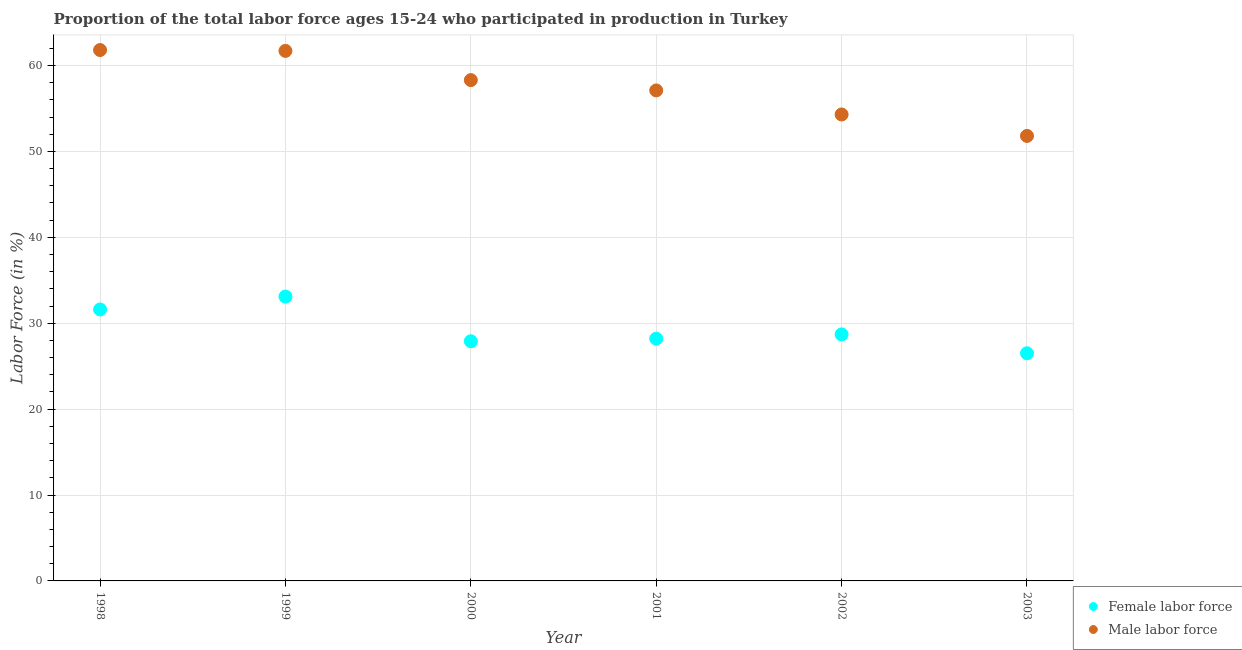Is the number of dotlines equal to the number of legend labels?
Your answer should be compact. Yes. What is the percentage of female labor force in 1999?
Your answer should be very brief. 33.1. Across all years, what is the maximum percentage of female labor force?
Offer a terse response. 33.1. Across all years, what is the minimum percentage of female labor force?
Make the answer very short. 26.5. In which year was the percentage of male labour force minimum?
Keep it short and to the point. 2003. What is the total percentage of female labor force in the graph?
Your response must be concise. 176. What is the difference between the percentage of female labor force in 2000 and that in 2002?
Offer a terse response. -0.8. What is the difference between the percentage of male labour force in 2002 and the percentage of female labor force in 1998?
Your answer should be compact. 22.7. What is the average percentage of female labor force per year?
Ensure brevity in your answer.  29.33. In the year 2000, what is the difference between the percentage of female labor force and percentage of male labour force?
Your answer should be very brief. -30.4. In how many years, is the percentage of female labor force greater than 58 %?
Offer a very short reply. 0. What is the ratio of the percentage of male labour force in 1998 to that in 2001?
Offer a very short reply. 1.08. Is the percentage of male labour force in 1998 less than that in 2002?
Provide a succinct answer. No. What is the difference between the highest and the second highest percentage of female labor force?
Give a very brief answer. 1.5. What is the difference between the highest and the lowest percentage of female labor force?
Ensure brevity in your answer.  6.6. Is the sum of the percentage of female labor force in 2000 and 2002 greater than the maximum percentage of male labour force across all years?
Make the answer very short. No. How many dotlines are there?
Provide a succinct answer. 2. What is the difference between two consecutive major ticks on the Y-axis?
Offer a terse response. 10. Are the values on the major ticks of Y-axis written in scientific E-notation?
Ensure brevity in your answer.  No. Does the graph contain any zero values?
Ensure brevity in your answer.  No. Does the graph contain grids?
Your answer should be very brief. Yes. How are the legend labels stacked?
Provide a succinct answer. Vertical. What is the title of the graph?
Provide a succinct answer. Proportion of the total labor force ages 15-24 who participated in production in Turkey. What is the label or title of the X-axis?
Offer a very short reply. Year. What is the Labor Force (in %) of Female labor force in 1998?
Offer a terse response. 31.6. What is the Labor Force (in %) in Male labor force in 1998?
Make the answer very short. 61.8. What is the Labor Force (in %) in Female labor force in 1999?
Offer a very short reply. 33.1. What is the Labor Force (in %) in Male labor force in 1999?
Offer a very short reply. 61.7. What is the Labor Force (in %) of Female labor force in 2000?
Keep it short and to the point. 27.9. What is the Labor Force (in %) of Male labor force in 2000?
Give a very brief answer. 58.3. What is the Labor Force (in %) in Female labor force in 2001?
Keep it short and to the point. 28.2. What is the Labor Force (in %) in Male labor force in 2001?
Make the answer very short. 57.1. What is the Labor Force (in %) of Female labor force in 2002?
Keep it short and to the point. 28.7. What is the Labor Force (in %) in Male labor force in 2002?
Provide a short and direct response. 54.3. What is the Labor Force (in %) of Male labor force in 2003?
Keep it short and to the point. 51.8. Across all years, what is the maximum Labor Force (in %) of Female labor force?
Ensure brevity in your answer.  33.1. Across all years, what is the maximum Labor Force (in %) in Male labor force?
Provide a succinct answer. 61.8. Across all years, what is the minimum Labor Force (in %) in Female labor force?
Your response must be concise. 26.5. Across all years, what is the minimum Labor Force (in %) of Male labor force?
Give a very brief answer. 51.8. What is the total Labor Force (in %) in Female labor force in the graph?
Ensure brevity in your answer.  176. What is the total Labor Force (in %) of Male labor force in the graph?
Make the answer very short. 345. What is the difference between the Labor Force (in %) of Female labor force in 1998 and that in 1999?
Provide a short and direct response. -1.5. What is the difference between the Labor Force (in %) of Male labor force in 1998 and that in 1999?
Your answer should be compact. 0.1. What is the difference between the Labor Force (in %) of Male labor force in 1998 and that in 2000?
Your answer should be compact. 3.5. What is the difference between the Labor Force (in %) of Female labor force in 1998 and that in 2001?
Provide a short and direct response. 3.4. What is the difference between the Labor Force (in %) in Male labor force in 1998 and that in 2001?
Offer a terse response. 4.7. What is the difference between the Labor Force (in %) in Male labor force in 1998 and that in 2002?
Your response must be concise. 7.5. What is the difference between the Labor Force (in %) of Female labor force in 1999 and that in 2000?
Your answer should be compact. 5.2. What is the difference between the Labor Force (in %) in Female labor force in 1999 and that in 2003?
Provide a succinct answer. 6.6. What is the difference between the Labor Force (in %) of Female labor force in 2000 and that in 2001?
Your answer should be very brief. -0.3. What is the difference between the Labor Force (in %) in Male labor force in 2000 and that in 2001?
Your response must be concise. 1.2. What is the difference between the Labor Force (in %) of Female labor force in 2000 and that in 2002?
Provide a succinct answer. -0.8. What is the difference between the Labor Force (in %) in Male labor force in 2000 and that in 2002?
Offer a very short reply. 4. What is the difference between the Labor Force (in %) of Female labor force in 2000 and that in 2003?
Offer a very short reply. 1.4. What is the difference between the Labor Force (in %) in Male labor force in 2000 and that in 2003?
Keep it short and to the point. 6.5. What is the difference between the Labor Force (in %) of Female labor force in 2001 and that in 2002?
Your response must be concise. -0.5. What is the difference between the Labor Force (in %) of Male labor force in 2001 and that in 2002?
Offer a terse response. 2.8. What is the difference between the Labor Force (in %) of Female labor force in 2001 and that in 2003?
Make the answer very short. 1.7. What is the difference between the Labor Force (in %) in Male labor force in 2001 and that in 2003?
Offer a terse response. 5.3. What is the difference between the Labor Force (in %) of Female labor force in 2002 and that in 2003?
Your answer should be very brief. 2.2. What is the difference between the Labor Force (in %) in Male labor force in 2002 and that in 2003?
Keep it short and to the point. 2.5. What is the difference between the Labor Force (in %) of Female labor force in 1998 and the Labor Force (in %) of Male labor force in 1999?
Give a very brief answer. -30.1. What is the difference between the Labor Force (in %) in Female labor force in 1998 and the Labor Force (in %) in Male labor force in 2000?
Provide a succinct answer. -26.7. What is the difference between the Labor Force (in %) of Female labor force in 1998 and the Labor Force (in %) of Male labor force in 2001?
Provide a short and direct response. -25.5. What is the difference between the Labor Force (in %) in Female labor force in 1998 and the Labor Force (in %) in Male labor force in 2002?
Your answer should be compact. -22.7. What is the difference between the Labor Force (in %) in Female labor force in 1998 and the Labor Force (in %) in Male labor force in 2003?
Give a very brief answer. -20.2. What is the difference between the Labor Force (in %) in Female labor force in 1999 and the Labor Force (in %) in Male labor force in 2000?
Your answer should be very brief. -25.2. What is the difference between the Labor Force (in %) of Female labor force in 1999 and the Labor Force (in %) of Male labor force in 2001?
Ensure brevity in your answer.  -24. What is the difference between the Labor Force (in %) of Female labor force in 1999 and the Labor Force (in %) of Male labor force in 2002?
Make the answer very short. -21.2. What is the difference between the Labor Force (in %) of Female labor force in 1999 and the Labor Force (in %) of Male labor force in 2003?
Offer a very short reply. -18.7. What is the difference between the Labor Force (in %) in Female labor force in 2000 and the Labor Force (in %) in Male labor force in 2001?
Ensure brevity in your answer.  -29.2. What is the difference between the Labor Force (in %) of Female labor force in 2000 and the Labor Force (in %) of Male labor force in 2002?
Provide a short and direct response. -26.4. What is the difference between the Labor Force (in %) of Female labor force in 2000 and the Labor Force (in %) of Male labor force in 2003?
Provide a succinct answer. -23.9. What is the difference between the Labor Force (in %) in Female labor force in 2001 and the Labor Force (in %) in Male labor force in 2002?
Make the answer very short. -26.1. What is the difference between the Labor Force (in %) in Female labor force in 2001 and the Labor Force (in %) in Male labor force in 2003?
Your answer should be very brief. -23.6. What is the difference between the Labor Force (in %) in Female labor force in 2002 and the Labor Force (in %) in Male labor force in 2003?
Your answer should be compact. -23.1. What is the average Labor Force (in %) in Female labor force per year?
Offer a very short reply. 29.33. What is the average Labor Force (in %) in Male labor force per year?
Offer a very short reply. 57.5. In the year 1998, what is the difference between the Labor Force (in %) in Female labor force and Labor Force (in %) in Male labor force?
Provide a short and direct response. -30.2. In the year 1999, what is the difference between the Labor Force (in %) in Female labor force and Labor Force (in %) in Male labor force?
Your answer should be compact. -28.6. In the year 2000, what is the difference between the Labor Force (in %) in Female labor force and Labor Force (in %) in Male labor force?
Provide a short and direct response. -30.4. In the year 2001, what is the difference between the Labor Force (in %) in Female labor force and Labor Force (in %) in Male labor force?
Offer a terse response. -28.9. In the year 2002, what is the difference between the Labor Force (in %) of Female labor force and Labor Force (in %) of Male labor force?
Your answer should be compact. -25.6. In the year 2003, what is the difference between the Labor Force (in %) in Female labor force and Labor Force (in %) in Male labor force?
Your answer should be compact. -25.3. What is the ratio of the Labor Force (in %) of Female labor force in 1998 to that in 1999?
Your response must be concise. 0.95. What is the ratio of the Labor Force (in %) of Female labor force in 1998 to that in 2000?
Your response must be concise. 1.13. What is the ratio of the Labor Force (in %) of Male labor force in 1998 to that in 2000?
Your response must be concise. 1.06. What is the ratio of the Labor Force (in %) in Female labor force in 1998 to that in 2001?
Offer a very short reply. 1.12. What is the ratio of the Labor Force (in %) in Male labor force in 1998 to that in 2001?
Provide a succinct answer. 1.08. What is the ratio of the Labor Force (in %) of Female labor force in 1998 to that in 2002?
Keep it short and to the point. 1.1. What is the ratio of the Labor Force (in %) of Male labor force in 1998 to that in 2002?
Your response must be concise. 1.14. What is the ratio of the Labor Force (in %) in Female labor force in 1998 to that in 2003?
Provide a short and direct response. 1.19. What is the ratio of the Labor Force (in %) in Male labor force in 1998 to that in 2003?
Give a very brief answer. 1.19. What is the ratio of the Labor Force (in %) of Female labor force in 1999 to that in 2000?
Make the answer very short. 1.19. What is the ratio of the Labor Force (in %) of Male labor force in 1999 to that in 2000?
Give a very brief answer. 1.06. What is the ratio of the Labor Force (in %) of Female labor force in 1999 to that in 2001?
Keep it short and to the point. 1.17. What is the ratio of the Labor Force (in %) in Male labor force in 1999 to that in 2001?
Your answer should be very brief. 1.08. What is the ratio of the Labor Force (in %) in Female labor force in 1999 to that in 2002?
Make the answer very short. 1.15. What is the ratio of the Labor Force (in %) in Male labor force in 1999 to that in 2002?
Your response must be concise. 1.14. What is the ratio of the Labor Force (in %) of Female labor force in 1999 to that in 2003?
Your answer should be very brief. 1.25. What is the ratio of the Labor Force (in %) of Male labor force in 1999 to that in 2003?
Make the answer very short. 1.19. What is the ratio of the Labor Force (in %) in Female labor force in 2000 to that in 2002?
Give a very brief answer. 0.97. What is the ratio of the Labor Force (in %) of Male labor force in 2000 to that in 2002?
Provide a succinct answer. 1.07. What is the ratio of the Labor Force (in %) of Female labor force in 2000 to that in 2003?
Your response must be concise. 1.05. What is the ratio of the Labor Force (in %) of Male labor force in 2000 to that in 2003?
Your answer should be very brief. 1.13. What is the ratio of the Labor Force (in %) of Female labor force in 2001 to that in 2002?
Your response must be concise. 0.98. What is the ratio of the Labor Force (in %) of Male labor force in 2001 to that in 2002?
Ensure brevity in your answer.  1.05. What is the ratio of the Labor Force (in %) of Female labor force in 2001 to that in 2003?
Give a very brief answer. 1.06. What is the ratio of the Labor Force (in %) in Male labor force in 2001 to that in 2003?
Keep it short and to the point. 1.1. What is the ratio of the Labor Force (in %) of Female labor force in 2002 to that in 2003?
Make the answer very short. 1.08. What is the ratio of the Labor Force (in %) in Male labor force in 2002 to that in 2003?
Give a very brief answer. 1.05. What is the difference between the highest and the lowest Labor Force (in %) in Female labor force?
Offer a very short reply. 6.6. What is the difference between the highest and the lowest Labor Force (in %) of Male labor force?
Make the answer very short. 10. 